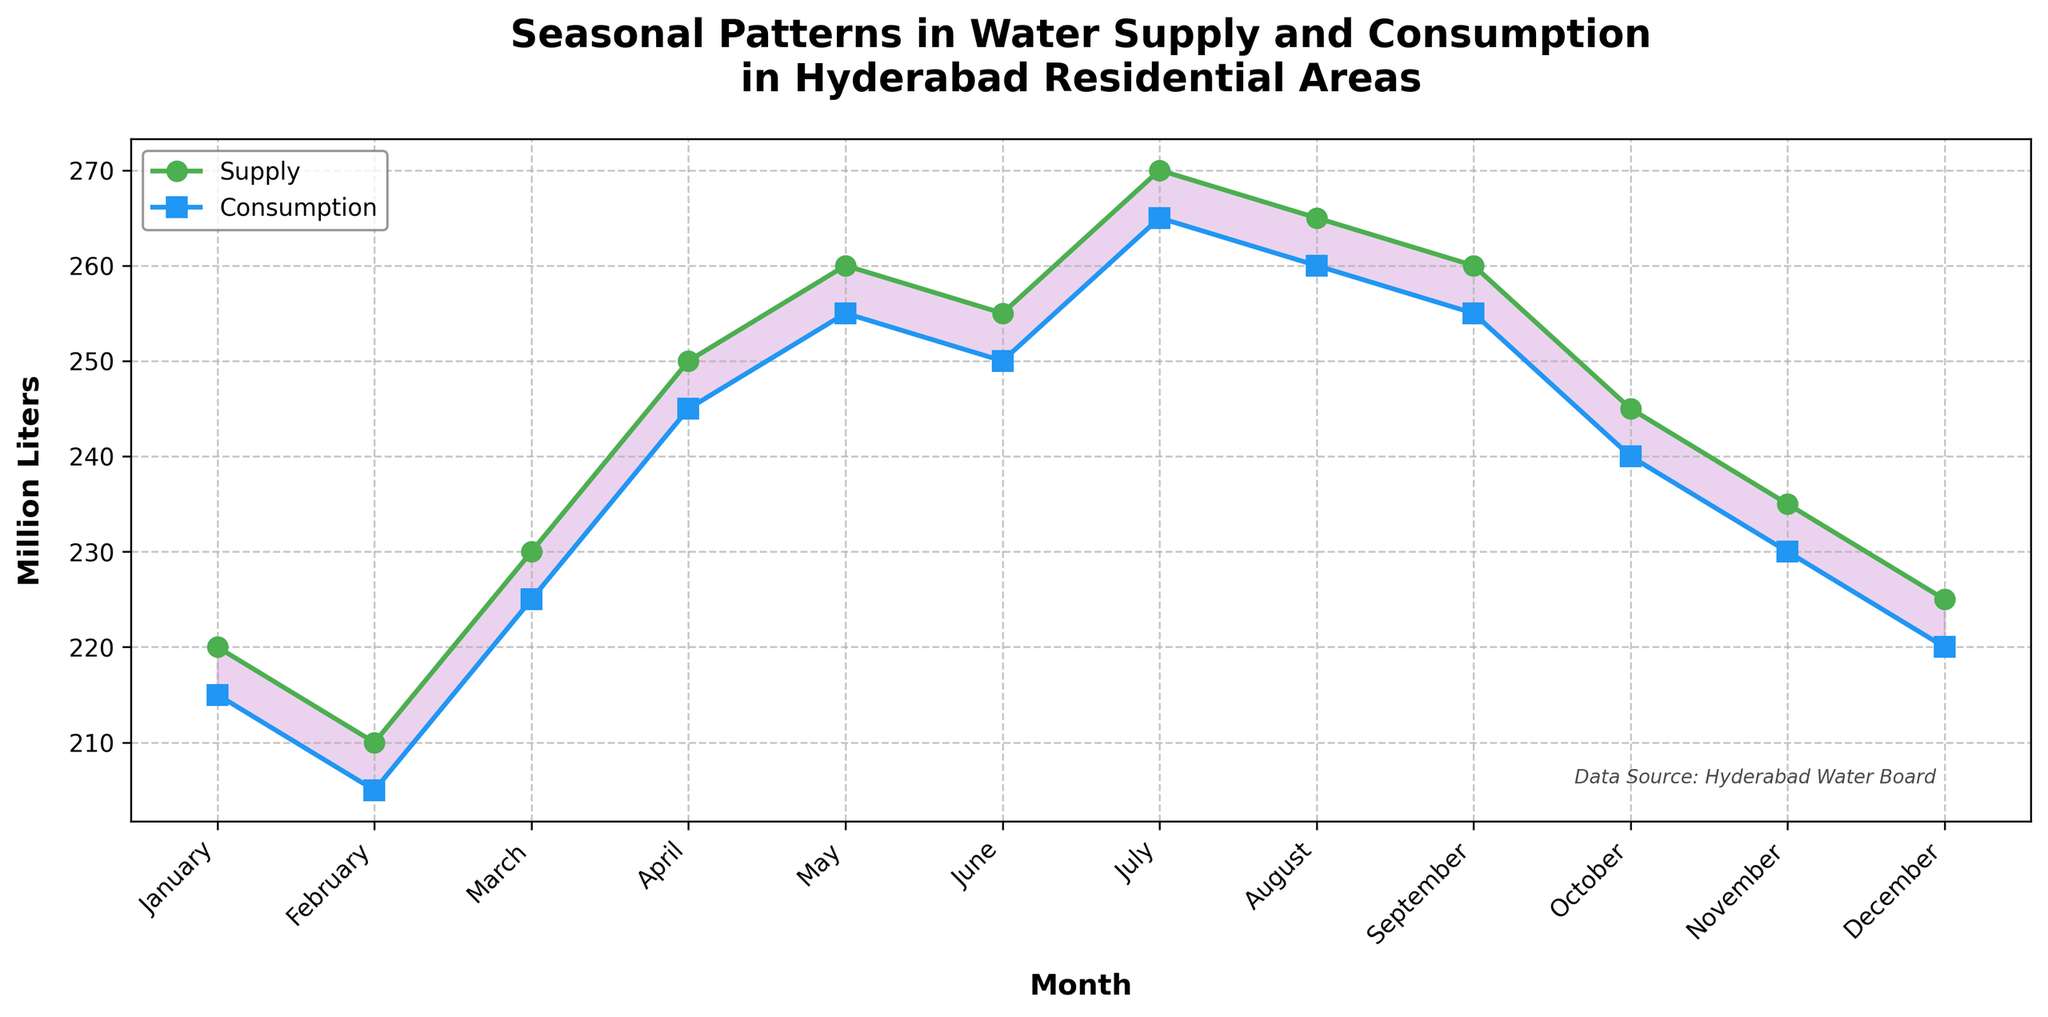How many months are there in the dataset? Count the number of data points along the x-axis labeled 'Month'.
Answer: 12 What are the two lines representing in the plot? Refer to the legend located at the upper left of the plot, which explains the lines labeled 'Supply' and 'Consumption'.
Answer: Water Supply and Water Consumption In which month is the water consumption the highest? Find the point with the highest value on the Water Consumption line (blue line), which is in July.
Answer: July What is the difference between water supply and consumption in June? Subtract the water consumption value from the water supply value in June (255 - 250).
Answer: 5 million liters Which month shows the largest gap between water supply and consumption? Identify the month where the area between the supply and consumption lines is the widest. It occurs in July (270 - 265).
Answer: July How does water supply compare to consumption in March? Compare the values of the Water Supply line and the Water Consumption line in March. Water supply is 230, and water consumption is 225.
Answer: Supply is higher by 5 million liters Is there any month where water consumption exceeds water supply? Observe all data points where the consumption line is higher than the supply line. No such month is visible in the plot.
Answer: No What's the average water supply over the year? Add all water supply values and divide by the number of months. Average = (220 + 210 + 230 + 250 + 260 + 255 + 270 + 265 + 260 + 245 + 235 + 225) / 12 = 246.67 million liters.
Answer: 246.67 million liters During which months is the water supply consistently above 240 million liters? Identify all months where the water supply line is more than 240. These months are April, May, June, July, August, and September.
Answer: April to September 